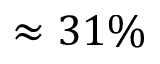Convert formula to latex. <formula><loc_0><loc_0><loc_500><loc_500>\approx 3 1 \%</formula> 